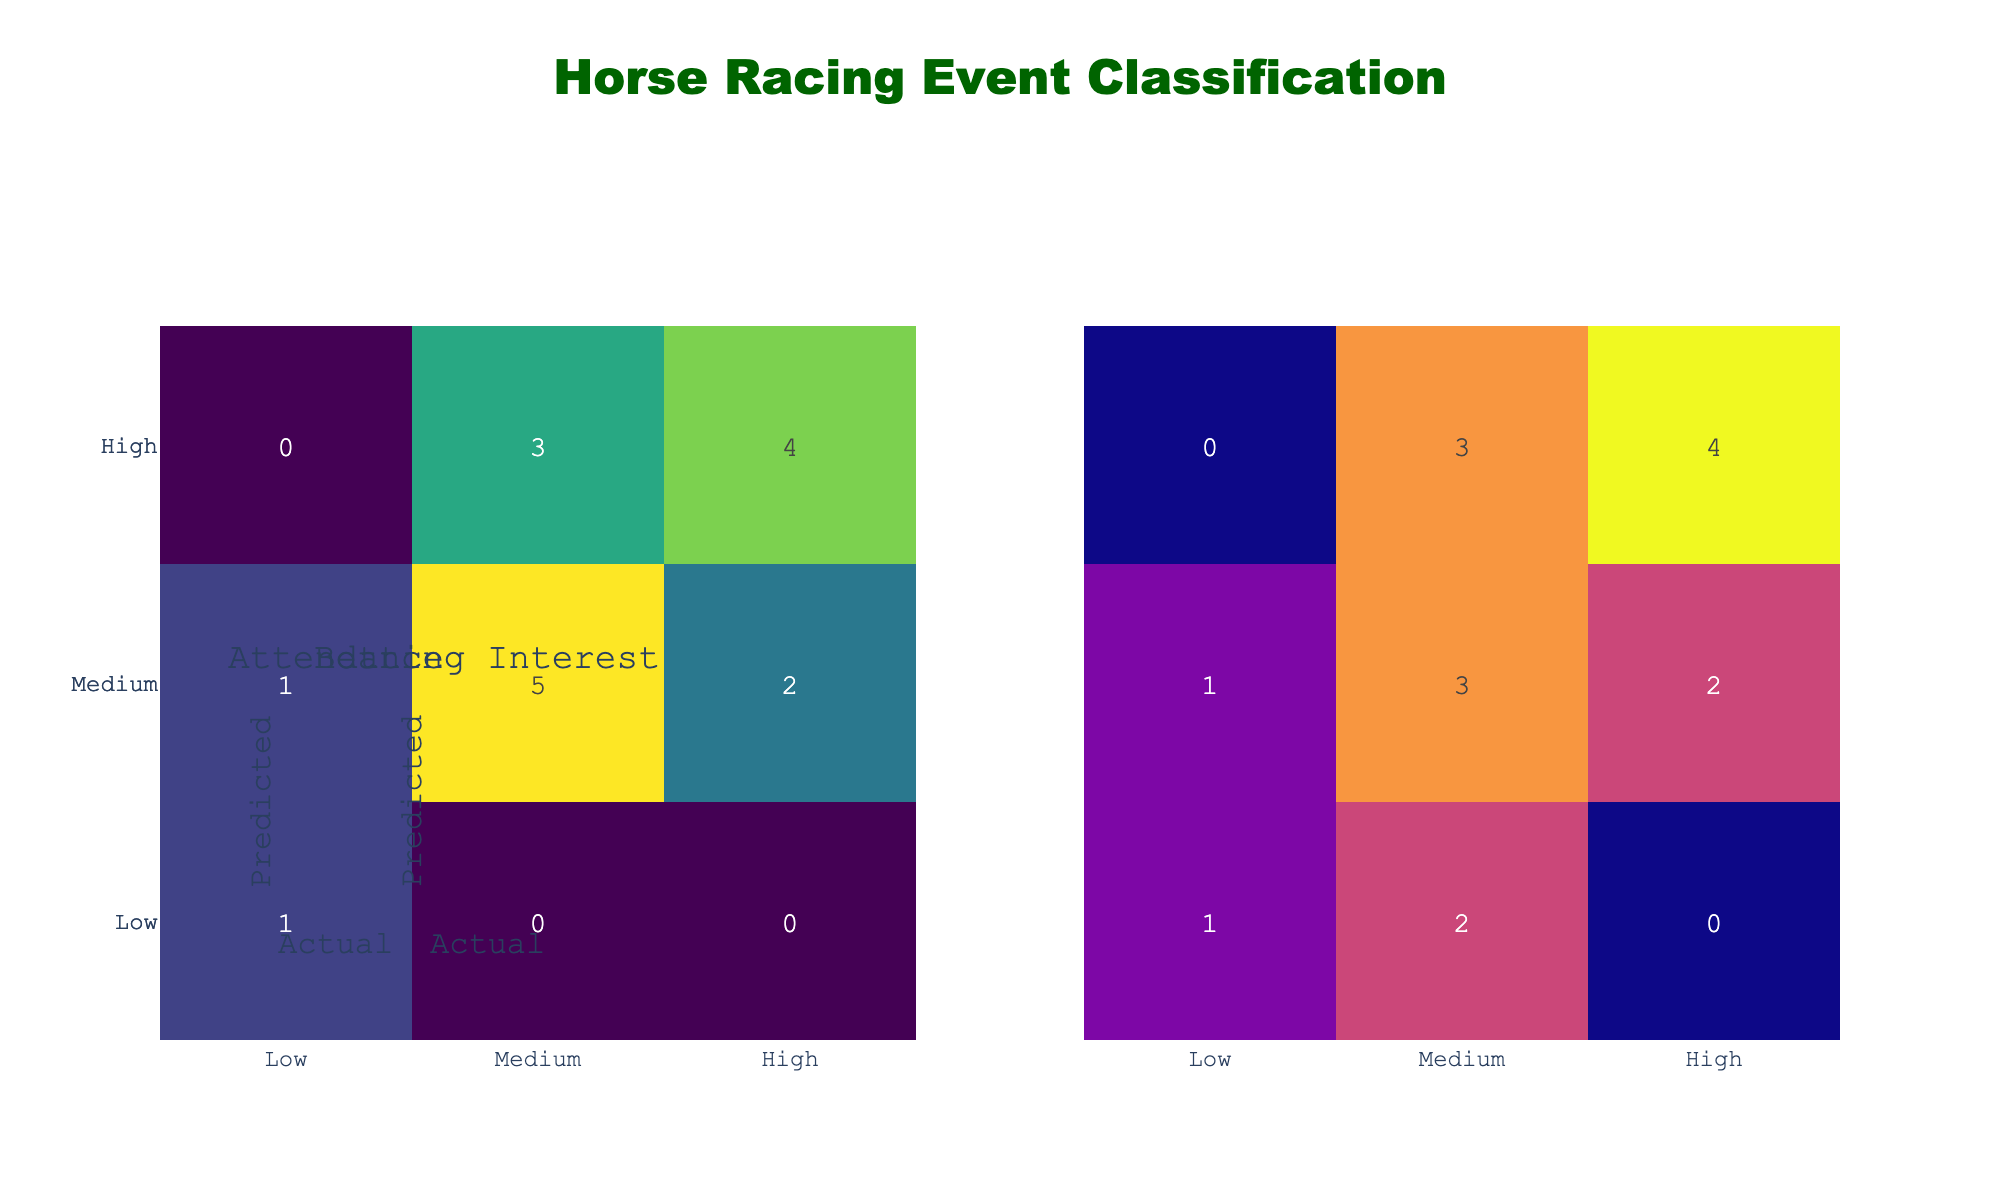What is the predicted attendance for the Grand National? The table shows that the predicted attendance for the Grand National is "High."
Answer: High How many events were predicted to have "Medium" attendance? By reviewing the table, the events categorized with "Medium" predicted attendance are the Preakness Stakes, Belmont Stakes, Dubai World Cup, Santa Anita Derby, and Travers Stakes, making a total of 5 events.
Answer: 5 Is it true that there are more events with high predicted betting interest than medium? Checking the table, the events with "High" predicted betting interest are the Kentucky Derby, Preakness Stakes, Royal Ascot, Grand National, Qatar Prix de l'Arc de Triomphe, and Monmouth Park Haskell totaling 6, while the events with "Medium" predicted betting interest total only 6 as well. Thus, the statement is false.
Answer: No What is the actual attendance for the Melbourne Cup? According to the table, the actual attendance for the Melbourne Cup is "High."
Answer: High How many events had both predicted and actual attendance classified as "High"? The events that both had predicted and actual attendance classified as "High" are the Kentucky Derby, Royal Ascot, and Grand National, totaling 3 events.
Answer: 3 What is the difference between the number of events with low predicted attendance compared to events with medium predicted attendance? From the table, the events with "Low" predicted attendance (Chester Cup) total 1, while those with "Medium" predicted attendance (Preakness Stakes, Belmont Stakes, Dubai World Cup, Santa Anita Derby, Travers Stakes, and Monmouth Park Haskell) total 6. The difference is 6 - 1 = 5.
Answer: 5 Is there any event where the predicted and actual betting interest are both "Low"? Upon examining the table, the Chester Cup is the only event where both the predicted and actual betting interest is classified as "Low." Therefore, the answer is yes.
Answer: Yes What fraction of events had a higher actual attendance than predicted attendance? Analyzing the table, the events where actual attendance is higher than predicted are the Melbourne Cup and Santa Anita Derby (2 events). There are 16 total events, so the fraction is 2/16, which simplifies to 1/8.
Answer: 1/8 